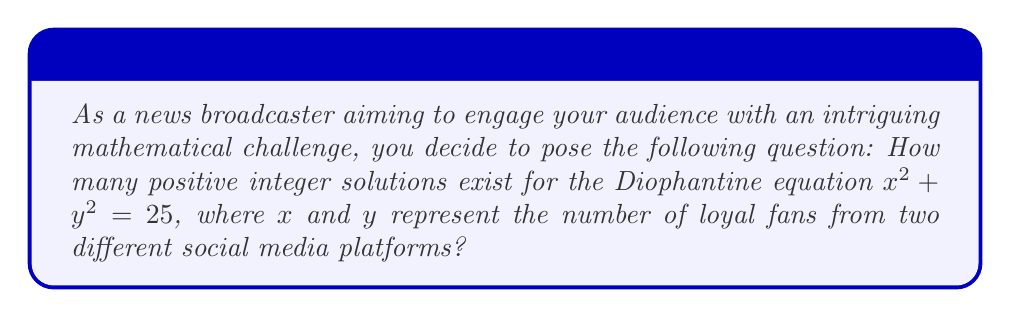Could you help me with this problem? Let's approach this step-by-step:

1) The equation $x^2 + y^2 = 25$ is a Diophantine equation, specifically a case of the Pythagorean theorem.

2) We need to find all positive integer pairs $(x,y)$ that satisfy this equation.

3) Since $x$ and $y$ are positive integers, we know that $1 \leq x \leq 4$ and $1 \leq y \leq 4$, because if either $x$ or $y$ were 5 or greater, the sum of their squares would exceed 25.

4) Let's consider the possible values:

   For $x = 1$: $1^2 + y^2 = 25$, so $y^2 = 24$, which has no integer solution.
   For $x = 2$: $2^2 + y^2 = 25$, so $y^2 = 21$, which has no integer solution.
   For $x = 3$: $3^2 + y^2 = 25$, so $y^2 = 16$, which gives $y = 4$.
   For $x = 4$: $4^2 + y^2 = 25$, so $y^2 = 9$, which gives $y = 3$.

5) Therefore, we have found two solutions: $(3,4)$ and $(4,3)$.

6) Note that these solutions are distinct in our context, as $x$ and $y$ represent fans from different platforms.

Thus, there are 2 positive integer solutions to this Diophantine equation.
Answer: 2 